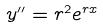<formula> <loc_0><loc_0><loc_500><loc_500>y ^ { \prime \prime } = r ^ { 2 } e ^ { r x }</formula> 